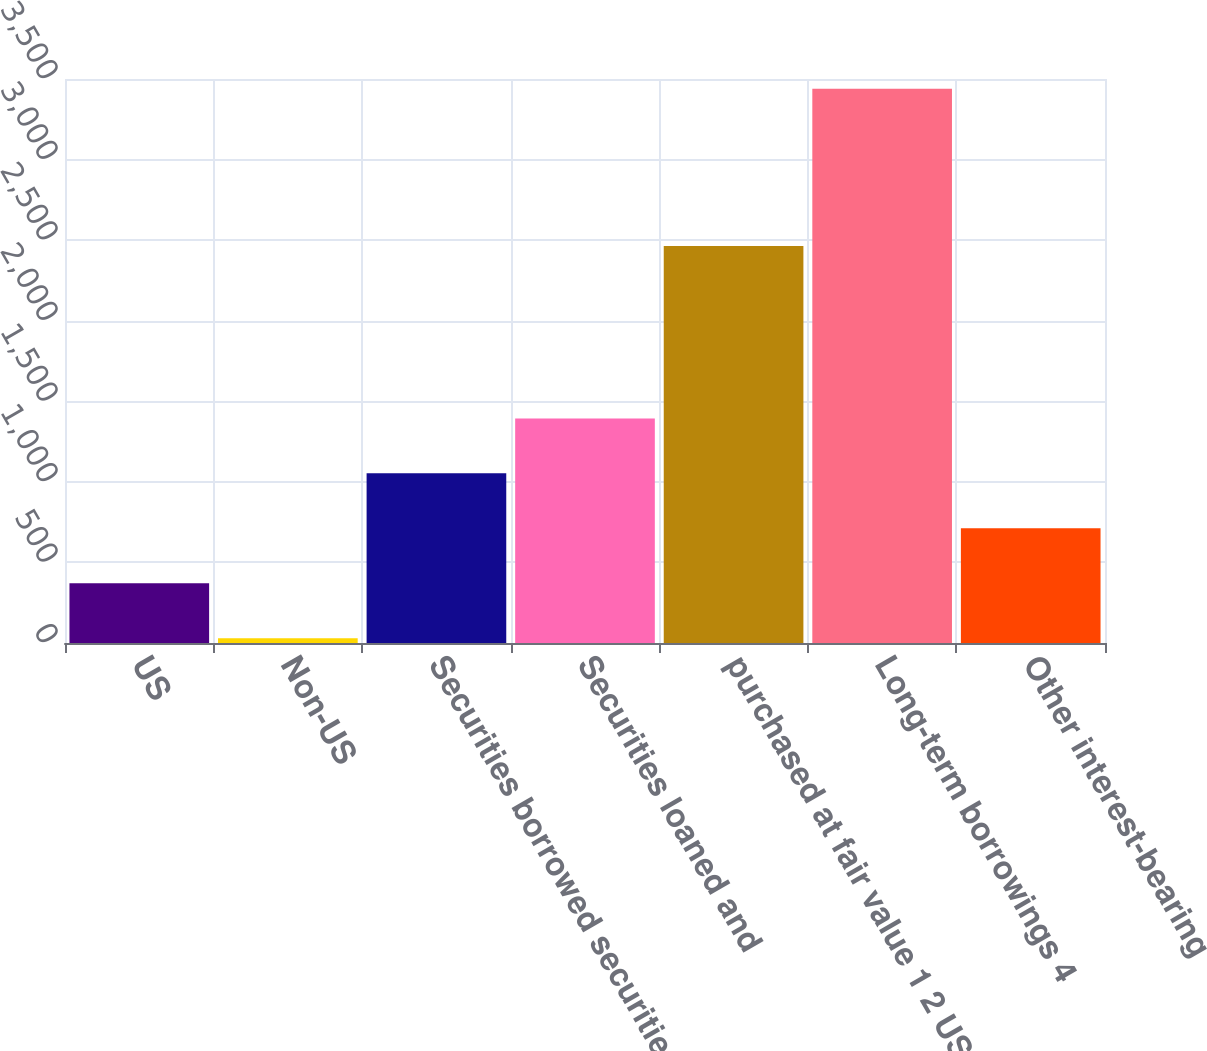Convert chart. <chart><loc_0><loc_0><loc_500><loc_500><bar_chart><fcel>US<fcel>Non-US<fcel>Securities borrowed securities<fcel>Securities loaned and<fcel>purchased at fair value 1 2 US<fcel>Long-term borrowings 4<fcel>Other interest-bearing<nl><fcel>370.9<fcel>30<fcel>1052.7<fcel>1393.6<fcel>2464<fcel>3439<fcel>711.8<nl></chart> 